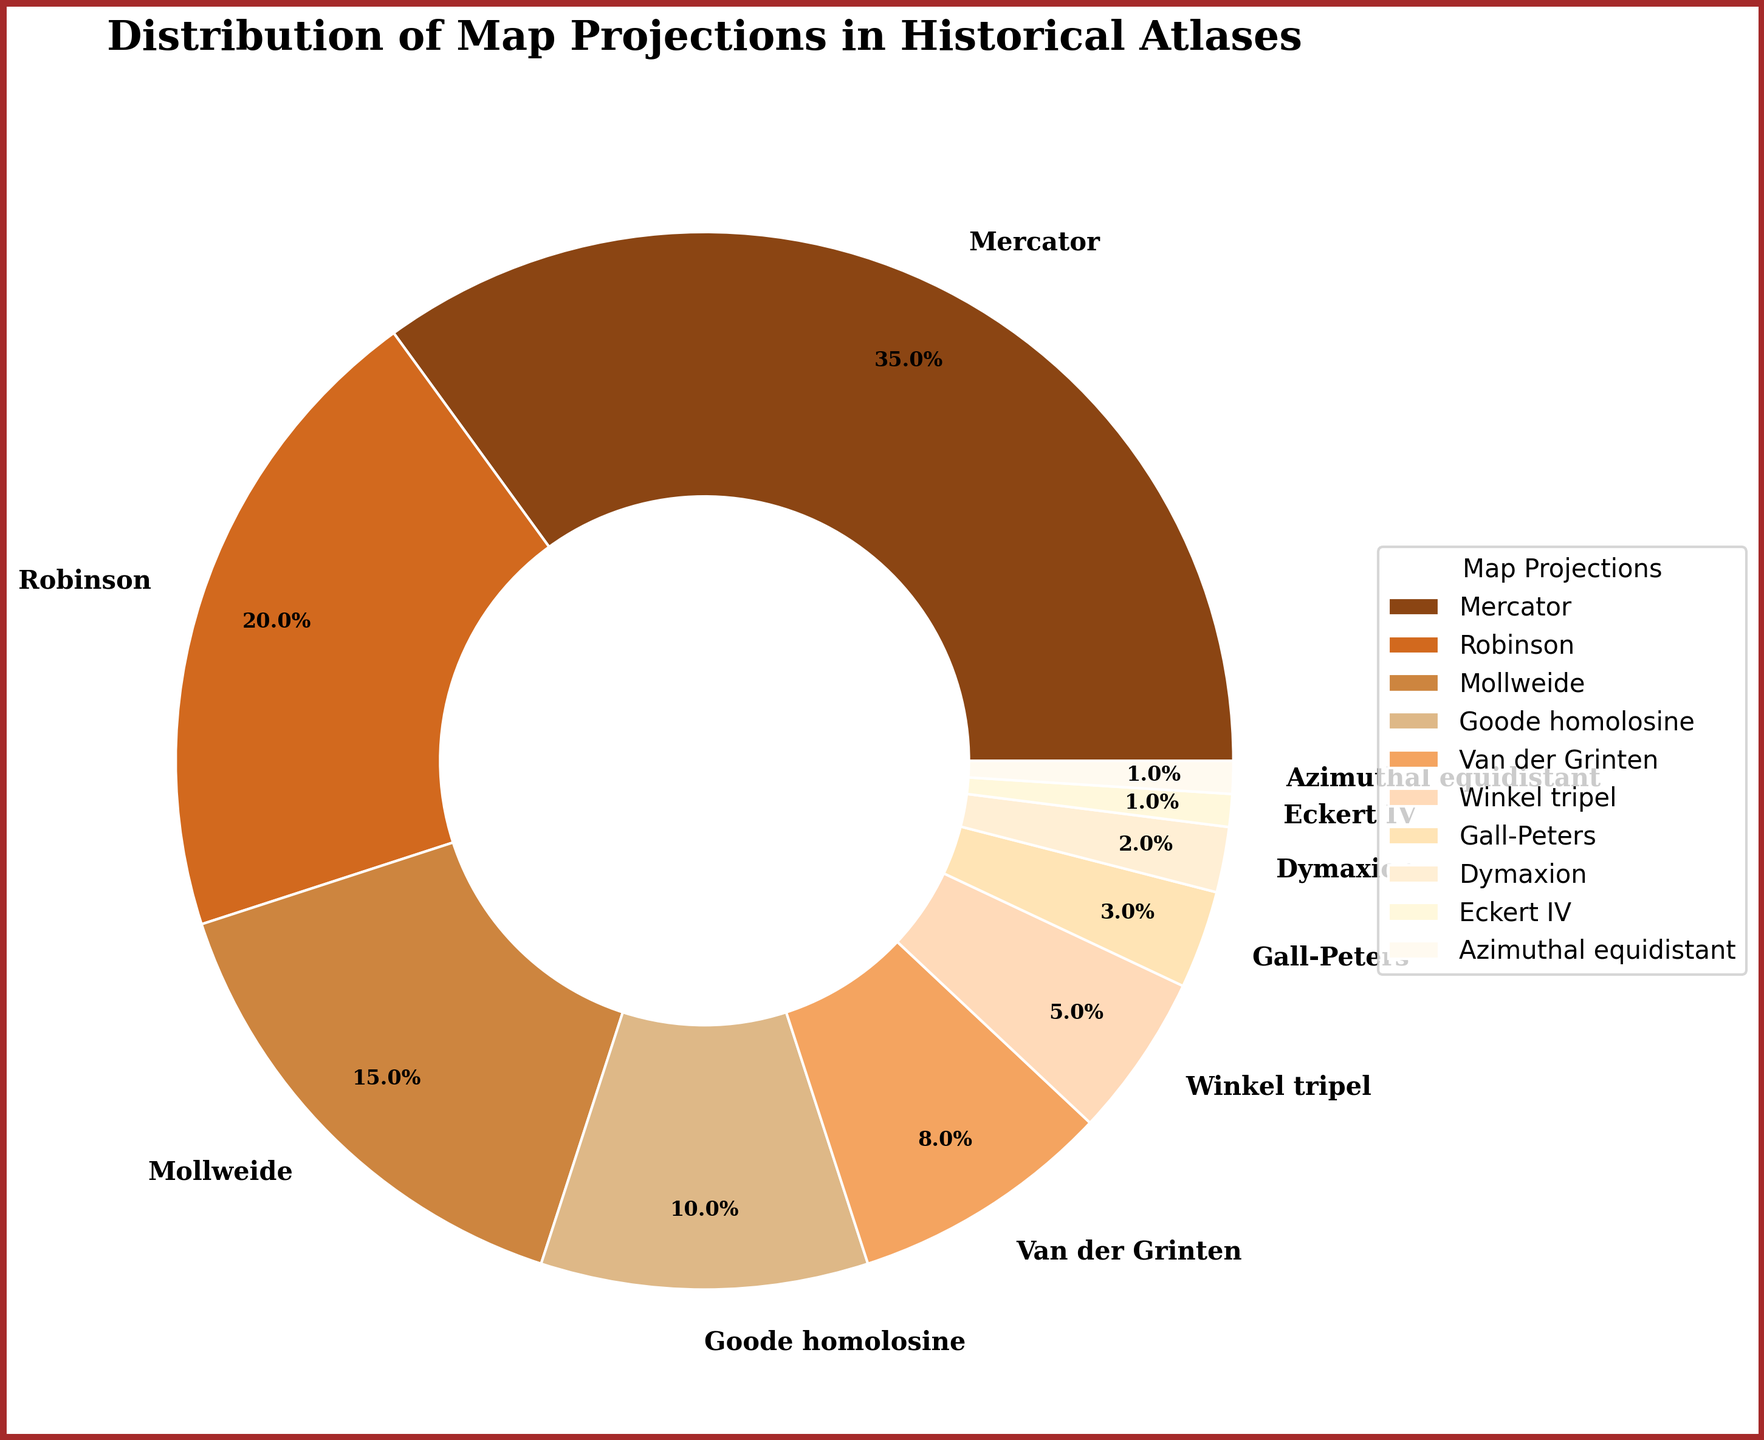Which projection is the most commonly used in historical atlases? The pie chart displays a labeled segment showing that the Mercator projection has the largest percentage, indicating it is the most commonly used in historical atlases.
Answer: Mercator What is the combined percentage of projections that each constitute less than 5%? The pie chart segments labeled Winkel tripel, Gall-Peters, Dymaxion, Eckert IV, and Azimuthal equidistant each have percentages of 5%, 3%, 2%, 1%, and 1% respectively. Adding these together: 5 + 3 + 2 + 1 + 1 equals 12%.
Answer: 12% How does the usage of Robinson projection compare to that of Goode homolosine projection? The pie chart shows that Robinson projection is labeled with 20% whereas Goode homolosine is labeled with 10%. 20% is significantly higher than 10%.
Answer: Robinson is used more Which two projections combined make up exactly 35% of the distribution? The percentages for Goode homolosine and Robinson are 10% and 20%, respectively. Combined, they sum up to 30%, not 35%. The next closest candidate is Robinson (20%) with Mollweide (15%) which sums to 20 + 15.
Answer: Molweide and Robinson What is the second least-used map projection in historical atlases? The pie chart reveals that Dymaxion, at 2%, is the second smallest segment after Eckert IV and Azimuthal equidistant at 1% each.
Answer: Dymaxion What percentage of the distribution is made up by Mercator and Robinson projections combined? The Mercator and Robinson projections have percentages of 35% and 20% respectively. Summing these gives 35 + 20 = 55%.
Answer: 55% Which segment, by color, represents the Van der Grinten projection? Van der Grinten is labeled with 8%, and the corresponding segment on the pie chart is colored a specific shade, in this case a brownish tone.
Answer: Brownish tone (depending on the palette provided) In terms of usage, which projection ranks fifth highest? The pie chart displays segments in descending order, and the fifth highest percentage is the segment labeled Van der Grinten at 8%.
Answer: Van der Grinten What is the visual difference in size between segments representing Goode homolosine and Winkel tripel? The Goode homolosine segment is labeled with 10% and the Winkel tripel with 5%. The Goode homolosine’s visual size is thus twice as large as Winkel tripel’s.
Answer: Goode homolosine is twice as large How many projections have a usage percentage less than 10%? The pie chart segments labeled with percentages show that Van der Grinten, Winkel tripel, Gall-Peters, Dymaxion, Eckert IV, and Azimuthal equidistant have percentages of 8%, 5%, 3%, 2%, 1%, and 1% respectively. Counting these gives 6 projections.
Answer: 6 